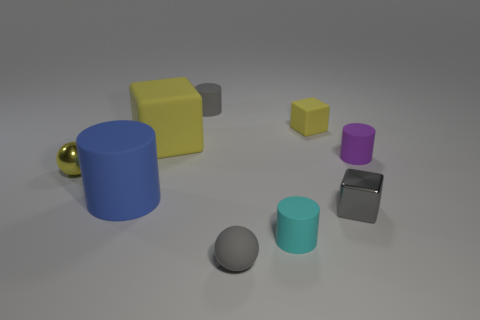Add 1 matte blocks. How many objects exist? 10 Subtract all spheres. How many objects are left? 7 Subtract all tiny brown matte things. Subtract all gray blocks. How many objects are left? 8 Add 4 large yellow matte cubes. How many large yellow matte cubes are left? 5 Add 2 tiny cyan matte spheres. How many tiny cyan matte spheres exist? 2 Subtract 0 red cylinders. How many objects are left? 9 